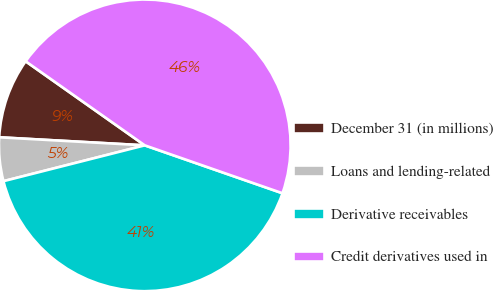Convert chart. <chart><loc_0><loc_0><loc_500><loc_500><pie_chart><fcel>December 31 (in millions)<fcel>Loans and lending-related<fcel>Derivative receivables<fcel>Credit derivatives used in<nl><fcel>8.9%<fcel>4.83%<fcel>40.72%<fcel>45.55%<nl></chart> 